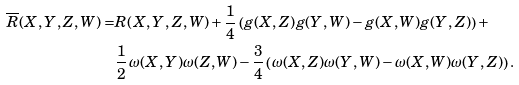<formula> <loc_0><loc_0><loc_500><loc_500>\overline { R } ( X , Y , Z , W ) = & R ( X , Y , Z , W ) + \frac { 1 } { 4 } \left ( g ( X , Z ) g ( Y , W ) - g ( X , W ) g ( Y , Z ) \right ) + \\ & \frac { 1 } { 2 } \, \omega ( X , Y ) \omega ( Z , W ) - \frac { 3 } { 4 } \left ( \omega ( X , Z ) \omega ( Y , W ) - \omega ( X , W ) \omega ( Y , Z ) \right ) .</formula> 